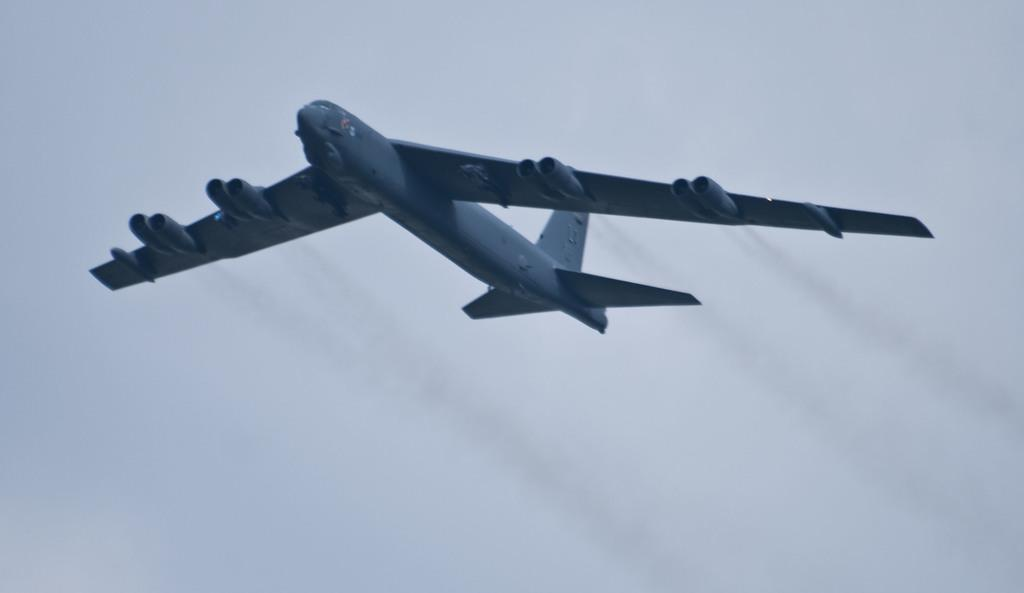What is the main subject of the image? The main subject of the image is an airplane. What is the airplane doing in the image? The airplane is flying in the sky. Reasoning: Let'g: Let's think step by step in order to produce the conversation. We start by identifying the main subject of the image, which is the airplane. Then, we describe the action of the airplane, which is flying in the sky. We avoid yes/no questions and ensure that the language is simple and clear. Absurd Question/Answer: What type of offer can be seen in the image? There is no offer present in the image; it features an airplane flying in the sky. Can you tell me how many brains are visible in the image? There are no brains visible in the image; it features an airplane flying in the sky. 